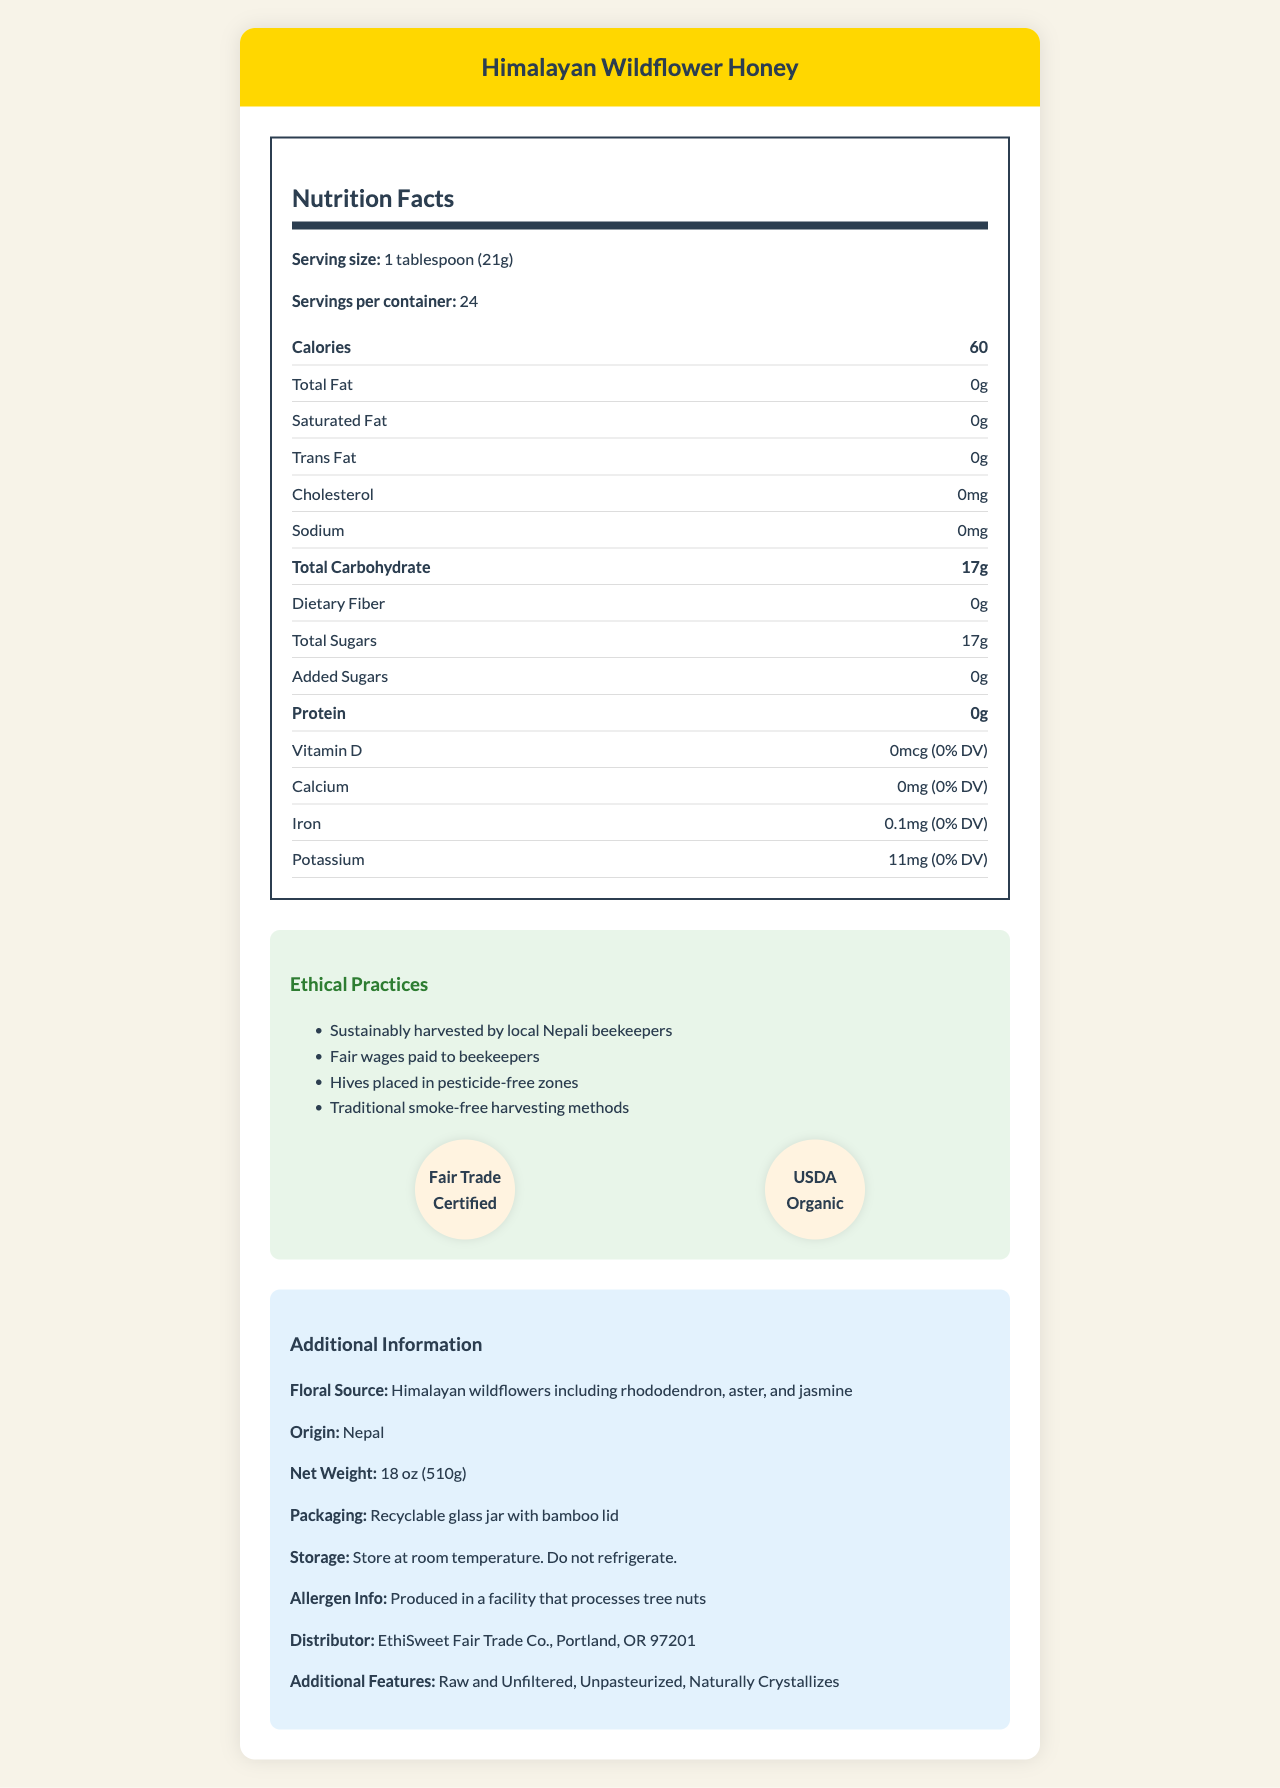what is the serving size? The serving size is listed clearly in the nutrition facts section as "1 tablespoon (21g)".
Answer: 1 tablespoon (21g) how many calories are there per serving? The calories per serving are mentioned in the main section of the nutrition facts as "Calories 60".
Answer: 60 calories what is the total carbohydrate content? The total carbohydrate content is listed as "Total Carbohydrate 17g" in the nutrition items list.
Answer: 17g is there any protein in this product? The section for protein in the nutrition facts indicates "0g".
Answer: No what is the floral source of the honey? The floral source is mentioned in the additional information section as "Himalayan wildflowers including rhododendron, aster, and jasmine".
Answer: Himalayan wildflowers including rhododendron, aster, and jasmine which of the following certifications does the product have? A. Fair Trade Certified B. USDA Organic C. Kosher D. All of the above The certifications section lists "Fair Trade Certified" and "USDA Organic," but not "Kosher." Therefore, correct options are A and B.
Answer: D. All of the above how many servings per container? The servings per container are stated in the nutrition facts as "Servings per container: 24".
Answer: 24 are there any added sugars in this honey? The label in the section for added sugars states "0g".
Answer: No does the product contain any dietary fiber? The dietary fiber content is listed as "0g" in the nutrition facts.
Answer: No how is the product harvested? A. Using modern mechanized methods B. Using traditional smoke-free harvesting methods C. Using pesticides The document mentions that this honey is harvested using "traditional smoke-free harvesting methods".
Answer: B. Using traditional smoke-free harvesting methods where is this product from? The country of origin is specified in the additional information as "Origin: Nepal".
Answer: Nepal is the honey raw and unfiltered? The additional information section states that the honey is "Raw and Unfiltered".
Answer: Yes does the jar lid contain any plastic? The packaging details mention a "bamboo lid," which suggests no plastic is used for the lid.
Answer: No explain the ethical practices mentioned. The ethical practices section lists these four points. This showcases the fair-trade and ethical principles governing the harvesting process.
Answer: 1. Sustainably harvested by local Nepali beekeepers, 2. Fair wages paid to beekeepers, 3. Hives placed in pesticide-free zones, 4. Traditional smoke-free harvesting methods who is the distributor of this product? The additional information mentions the distributor as "EthiSweet Fair Trade Co., Portland, OR 97201".
Answer: EthiSweet Fair Trade Co. summarize the whole document. The nutrition facts label for Himalayan Wildflower Honey details its serving size, calorie count, and breakdown of fat, carbohydrates, and protein content. It also emphasizes ethical harvesting practices and certifications, showcases additional quality attributes (e.g., being raw and unfiltered), storage instructions, and distributor information to provide a comprehensive overview to the consumers.
Answer: The document presents comprehensive information about Himalayan Wildflower Honey, focusing on its nutritional facts, ethical beekeeping practices, certifications, and additional details like its floral source and storage recommendations. This honey is fair-trade certified, USDA Organic, raw, unfiltered, and sustainably harvested by local Nepali beekeepers using traditional methods. It comes in a recyclable glass jar with a bamboo lid and includes information for consumers regarding allergen processing and distributor details. which vitamin content is listed in the nutrition facts? The nutritional facts section lists "Vitamin D" with the quantity "0mcg (0% DV)".
Answer: Vitamin D what is the price of the product? The document does not contain any information about the price of the product.
Answer: Cannot be determined 